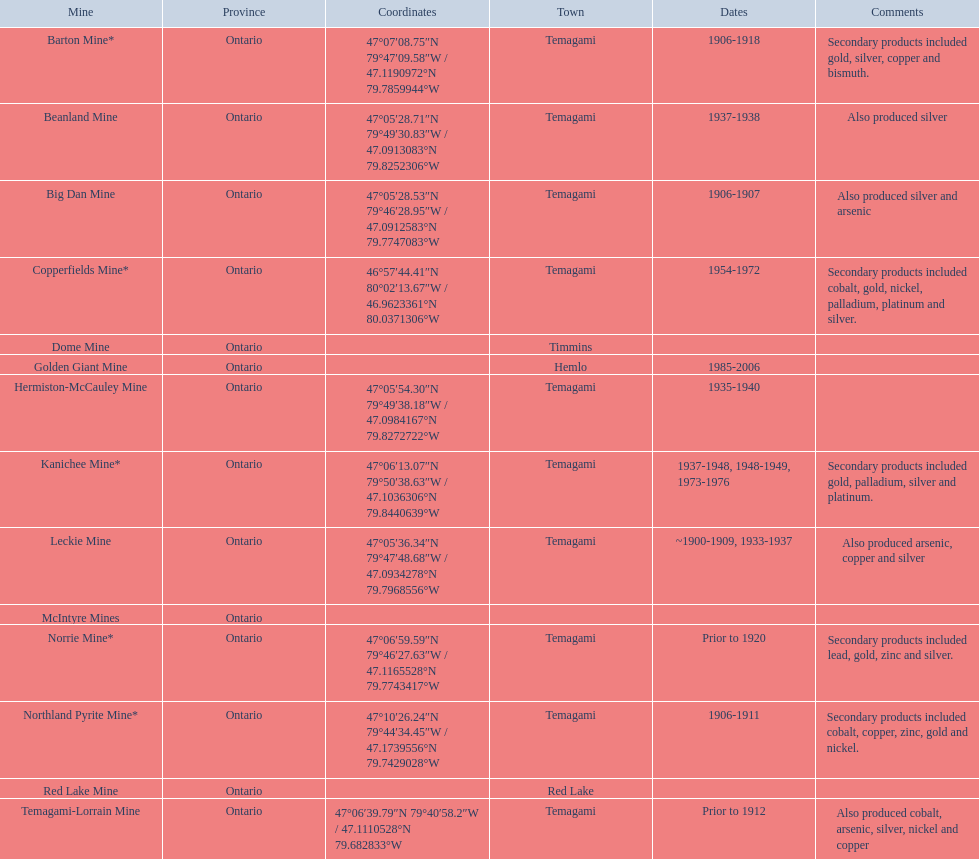What years was the golden giant mine open for? 1985-2006. What years was the beanland mine open? 1937-1938. Which of these two mines was open longer? Golden Giant Mine. 